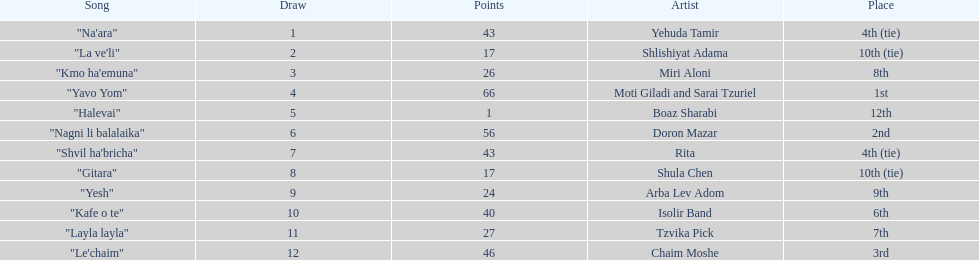Did the song "gitara" or "yesh" earn more points? "Yesh". 